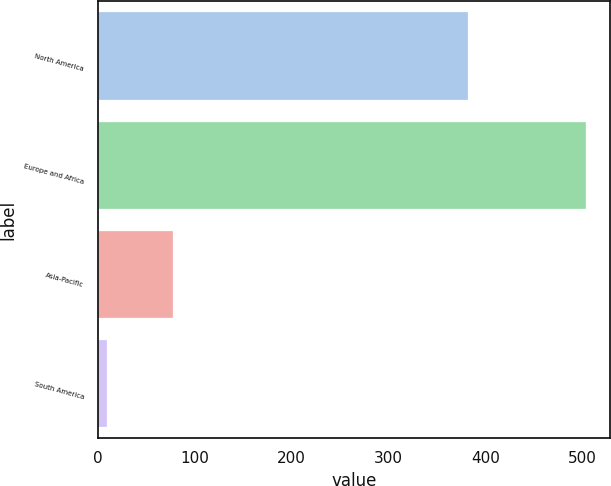Convert chart to OTSL. <chart><loc_0><loc_0><loc_500><loc_500><bar_chart><fcel>North America<fcel>Europe and Africa<fcel>Asia-Pacific<fcel>South America<nl><fcel>382<fcel>504<fcel>78<fcel>10<nl></chart> 